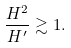Convert formula to latex. <formula><loc_0><loc_0><loc_500><loc_500>\frac { H ^ { 2 } } { H ^ { \prime } } \gtrsim 1 .</formula> 